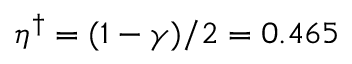<formula> <loc_0><loc_0><loc_500><loc_500>\eta ^ { \dagger } = ( 1 - \gamma ) / 2 = 0 . 4 6 5</formula> 